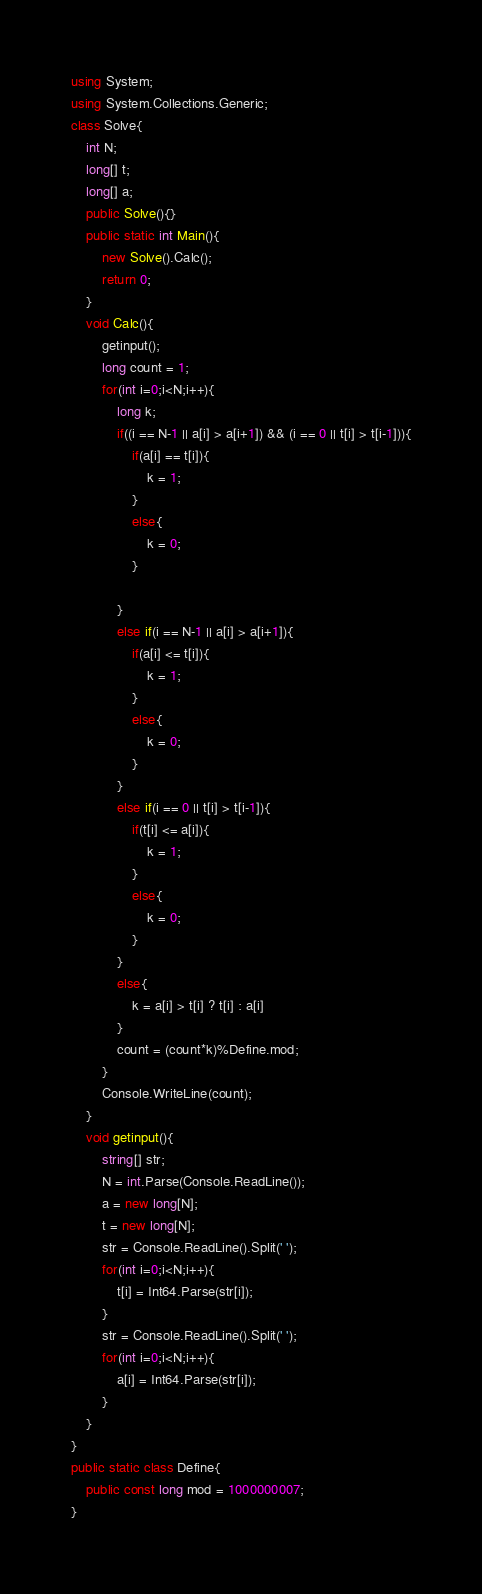Convert code to text. <code><loc_0><loc_0><loc_500><loc_500><_C#_>using System;
using System.Collections.Generic;
class Solve{
    int N;
    long[] t;
    long[] a;
    public Solve(){}
    public static int Main(){
        new Solve().Calc();
        return 0;
    }
    void Calc(){
        getinput();
        long count = 1;
        for(int i=0;i<N;i++){
            long k;
            if((i == N-1 || a[i] > a[i+1]) && (i == 0 || t[i] > t[i-1])){
                if(a[i] == t[i]){
                    k = 1;
                }
                else{
                    k = 0;
                }
                
            }
            else if(i == N-1 || a[i] > a[i+1]){
                if(a[i] <= t[i]){
                    k = 1;
                }
                else{
                    k = 0;
                }
            }
            else if(i == 0 || t[i] > t[i-1]){
                if(t[i] <= a[i]){
                    k = 1;
                }
                else{
                    k = 0;
                }
            }
            else{
                k = a[i] > t[i] ? t[i] : a[i] 
            }
            count = (count*k)%Define.mod;
        }
        Console.WriteLine(count);
    }
    void getinput(){
        string[] str;
        N = int.Parse(Console.ReadLine());
        a = new long[N];
        t = new long[N];
        str = Console.ReadLine().Split(' ');
        for(int i=0;i<N;i++){
            t[i] = Int64.Parse(str[i]);
        }
        str = Console.ReadLine().Split(' ');
        for(int i=0;i<N;i++){
            a[i] = Int64.Parse(str[i]);
        }
    }    
}
public static class Define{
    public const long mod = 1000000007;
}</code> 